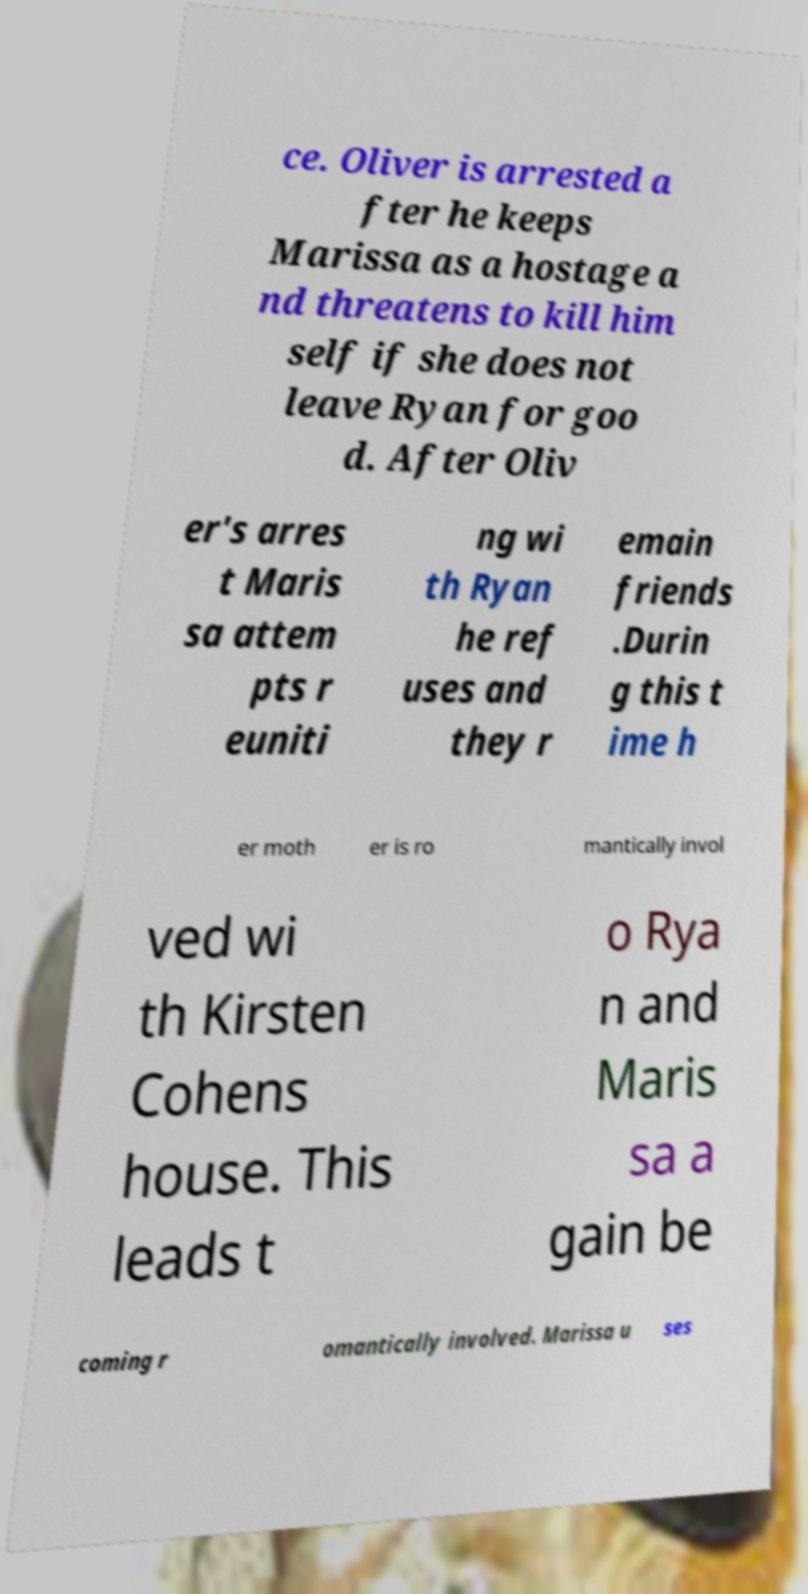For documentation purposes, I need the text within this image transcribed. Could you provide that? ce. Oliver is arrested a fter he keeps Marissa as a hostage a nd threatens to kill him self if she does not leave Ryan for goo d. After Oliv er's arres t Maris sa attem pts r euniti ng wi th Ryan he ref uses and they r emain friends .Durin g this t ime h er moth er is ro mantically invol ved wi th Kirsten Cohens house. This leads t o Rya n and Maris sa a gain be coming r omantically involved. Marissa u ses 